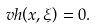<formula> <loc_0><loc_0><loc_500><loc_500>v h { \left ( x , \xi \right ) } = 0 .</formula> 